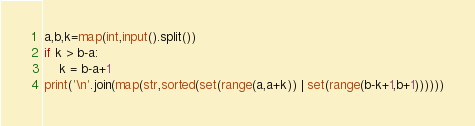Convert code to text. <code><loc_0><loc_0><loc_500><loc_500><_Python_>a,b,k=map(int,input().split())
if k > b-a:
    k = b-a+1
print('\n'.join(map(str,sorted(set(range(a,a+k)) | set(range(b-k+1,b+1))))))
</code> 